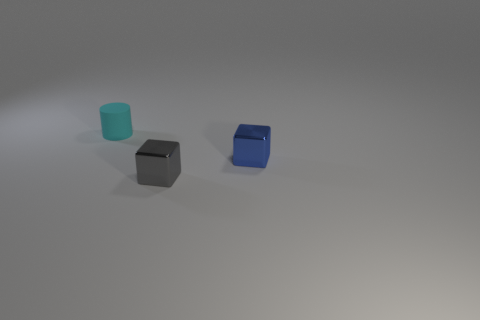Do the cube right of the gray metal object and the matte object have the same color?
Offer a terse response. No. There is a small metallic object behind the tiny gray object; how many blue metal things are on the left side of it?
Make the answer very short. 0. What color is the metal thing that is the same size as the gray block?
Provide a succinct answer. Blue. What is the material of the small block right of the small gray metal cube?
Your response must be concise. Metal. What is the thing that is behind the gray object and in front of the cyan cylinder made of?
Offer a very short reply. Metal. Is the size of the metallic thing in front of the blue object the same as the blue block?
Offer a terse response. Yes. The blue object has what shape?
Your answer should be very brief. Cube. What number of other tiny things are the same shape as the small blue metal object?
Offer a terse response. 1. What number of things are behind the tiny gray thing and in front of the small rubber object?
Your response must be concise. 1. What is the color of the matte object?
Provide a succinct answer. Cyan. 